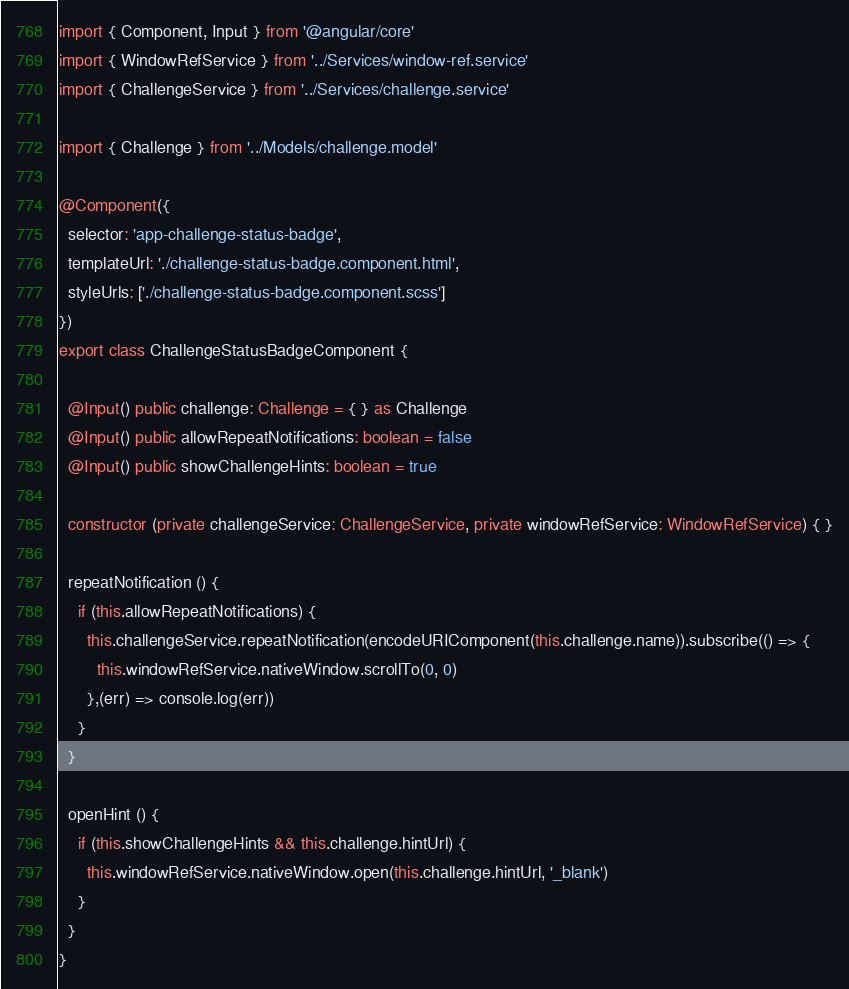Convert code to text. <code><loc_0><loc_0><loc_500><loc_500><_TypeScript_>import { Component, Input } from '@angular/core'
import { WindowRefService } from '../Services/window-ref.service'
import { ChallengeService } from '../Services/challenge.service'

import { Challenge } from '../Models/challenge.model'

@Component({
  selector: 'app-challenge-status-badge',
  templateUrl: './challenge-status-badge.component.html',
  styleUrls: ['./challenge-status-badge.component.scss']
})
export class ChallengeStatusBadgeComponent {

  @Input() public challenge: Challenge = { } as Challenge
  @Input() public allowRepeatNotifications: boolean = false
  @Input() public showChallengeHints: boolean = true

  constructor (private challengeService: ChallengeService, private windowRefService: WindowRefService) { }

  repeatNotification () {
    if (this.allowRepeatNotifications) {
      this.challengeService.repeatNotification(encodeURIComponent(this.challenge.name)).subscribe(() => {
        this.windowRefService.nativeWindow.scrollTo(0, 0)
      },(err) => console.log(err))
    }
  }

  openHint () {
    if (this.showChallengeHints && this.challenge.hintUrl) {
      this.windowRefService.nativeWindow.open(this.challenge.hintUrl, '_blank')
    }
  }
}
</code> 